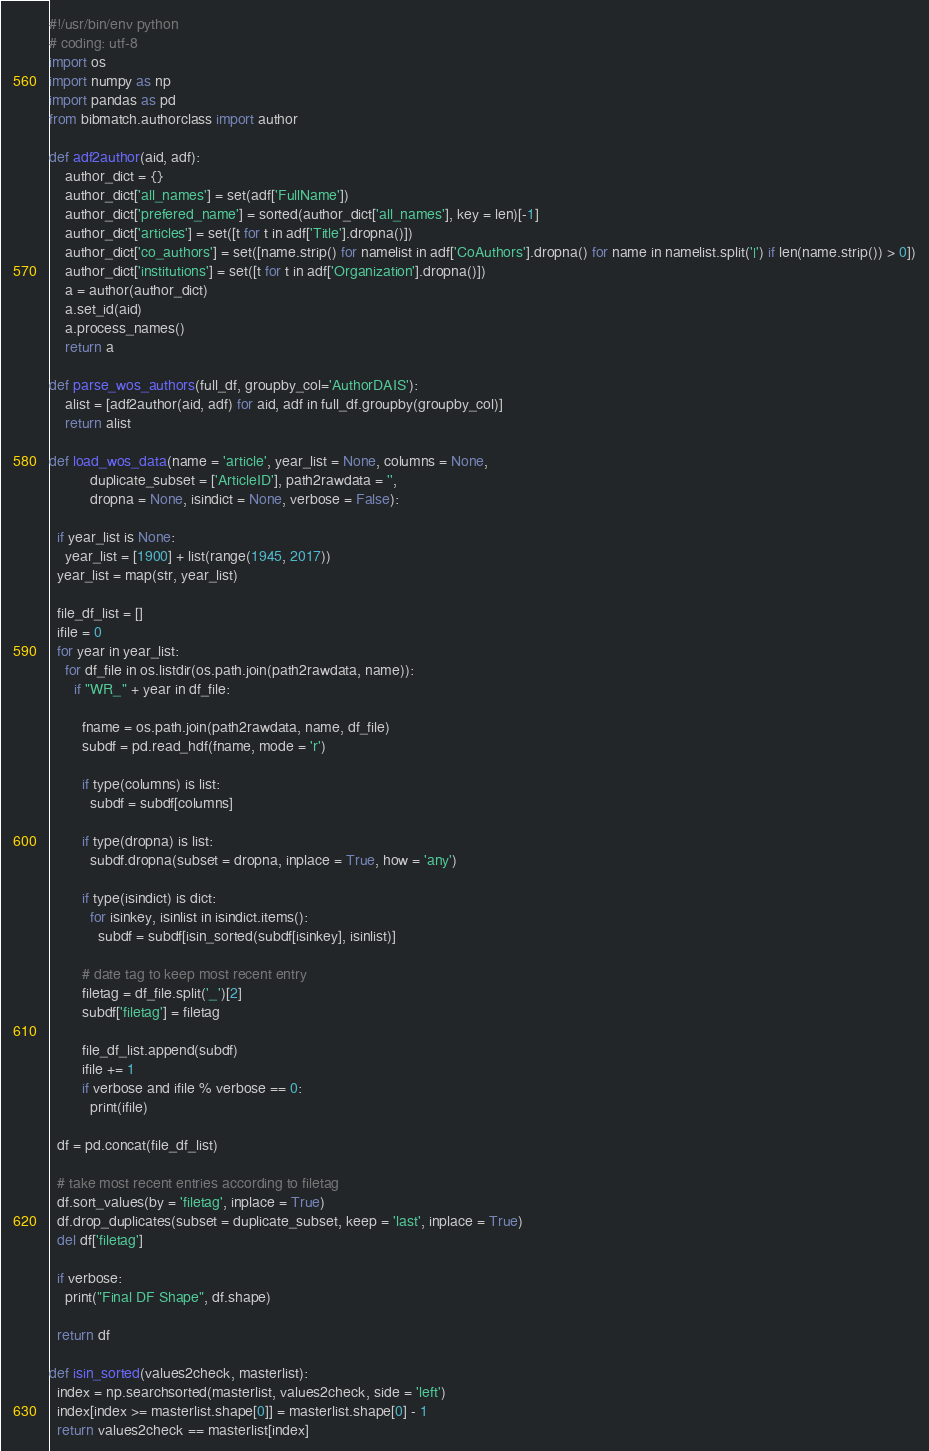<code> <loc_0><loc_0><loc_500><loc_500><_Python_>#!/usr/bin/env python
# coding: utf-8
import os
import numpy as np
import pandas as pd
from bibmatch.authorclass import author

def adf2author(aid, adf):
    author_dict = {}
    author_dict['all_names'] = set(adf['FullName'])
    author_dict['prefered_name'] = sorted(author_dict['all_names'], key = len)[-1]
    author_dict['articles'] = set([t for t in adf['Title'].dropna()])
    author_dict['co_authors'] = set([name.strip() for namelist in adf['CoAuthors'].dropna() for name in namelist.split('|') if len(name.strip()) > 0])
    author_dict['institutions'] = set([t for t in adf['Organization'].dropna()])
    a = author(author_dict)
    a.set_id(aid)
    a.process_names()
    return a

def parse_wos_authors(full_df, groupby_col='AuthorDAIS'):
    alist = [adf2author(aid, adf) for aid, adf in full_df.groupby(groupby_col)]
    return alist

def load_wos_data(name = 'article', year_list = None, columns = None,
          duplicate_subset = ['ArticleID'], path2rawdata = '',
          dropna = None, isindict = None, verbose = False):

  if year_list is None:
    year_list = [1900] + list(range(1945, 2017))
  year_list = map(str, year_list)

  file_df_list = []
  ifile = 0
  for year in year_list:
    for df_file in os.listdir(os.path.join(path2rawdata, name)):
      if "WR_" + year in df_file:

        fname = os.path.join(path2rawdata, name, df_file)
        subdf = pd.read_hdf(fname, mode = 'r')

        if type(columns) is list:
          subdf = subdf[columns]

        if type(dropna) is list:
          subdf.dropna(subset = dropna, inplace = True, how = 'any')

        if type(isindict) is dict:
          for isinkey, isinlist in isindict.items():
            subdf = subdf[isin_sorted(subdf[isinkey], isinlist)]

        # date tag to keep most recent entry
        filetag = df_file.split('_')[2]
        subdf['filetag'] = filetag

        file_df_list.append(subdf)
        ifile += 1
        if verbose and ifile % verbose == 0:
          print(ifile)

  df = pd.concat(file_df_list)

  # take most recent entries according to filetag
  df.sort_values(by = 'filetag', inplace = True)
  df.drop_duplicates(subset = duplicate_subset, keep = 'last', inplace = True)
  del df['filetag']

  if verbose:
    print("Final DF Shape", df.shape)

  return df

def isin_sorted(values2check, masterlist):
  index = np.searchsorted(masterlist, values2check, side = 'left')
  index[index >= masterlist.shape[0]] = masterlist.shape[0] - 1
  return values2check == masterlist[index]</code> 